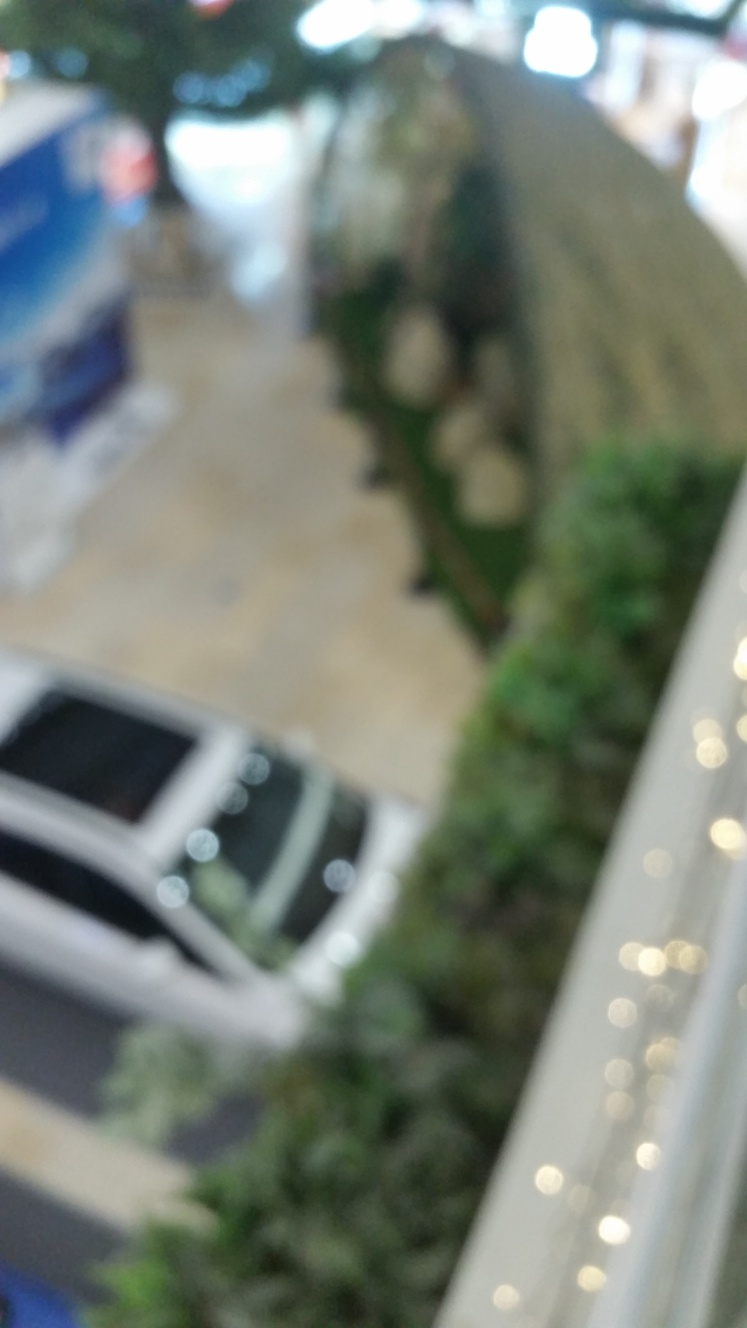What kind of activities do you think typically occur in this place? In a setting such as this, one might expect activities like shopping, dining, socializing, or simply transiting through the area. It could be a location where friends meet up, families spend time together on weekends, or individuals shop for various goods and services. Is there anything in this image that indicates the time of day? The image's quality issue makes it difficult to determine the time of day with precision. However, the presence of artificial lighting might suggest it is either nighttime or an indoor environment that relies on illumination during all opening hours. 